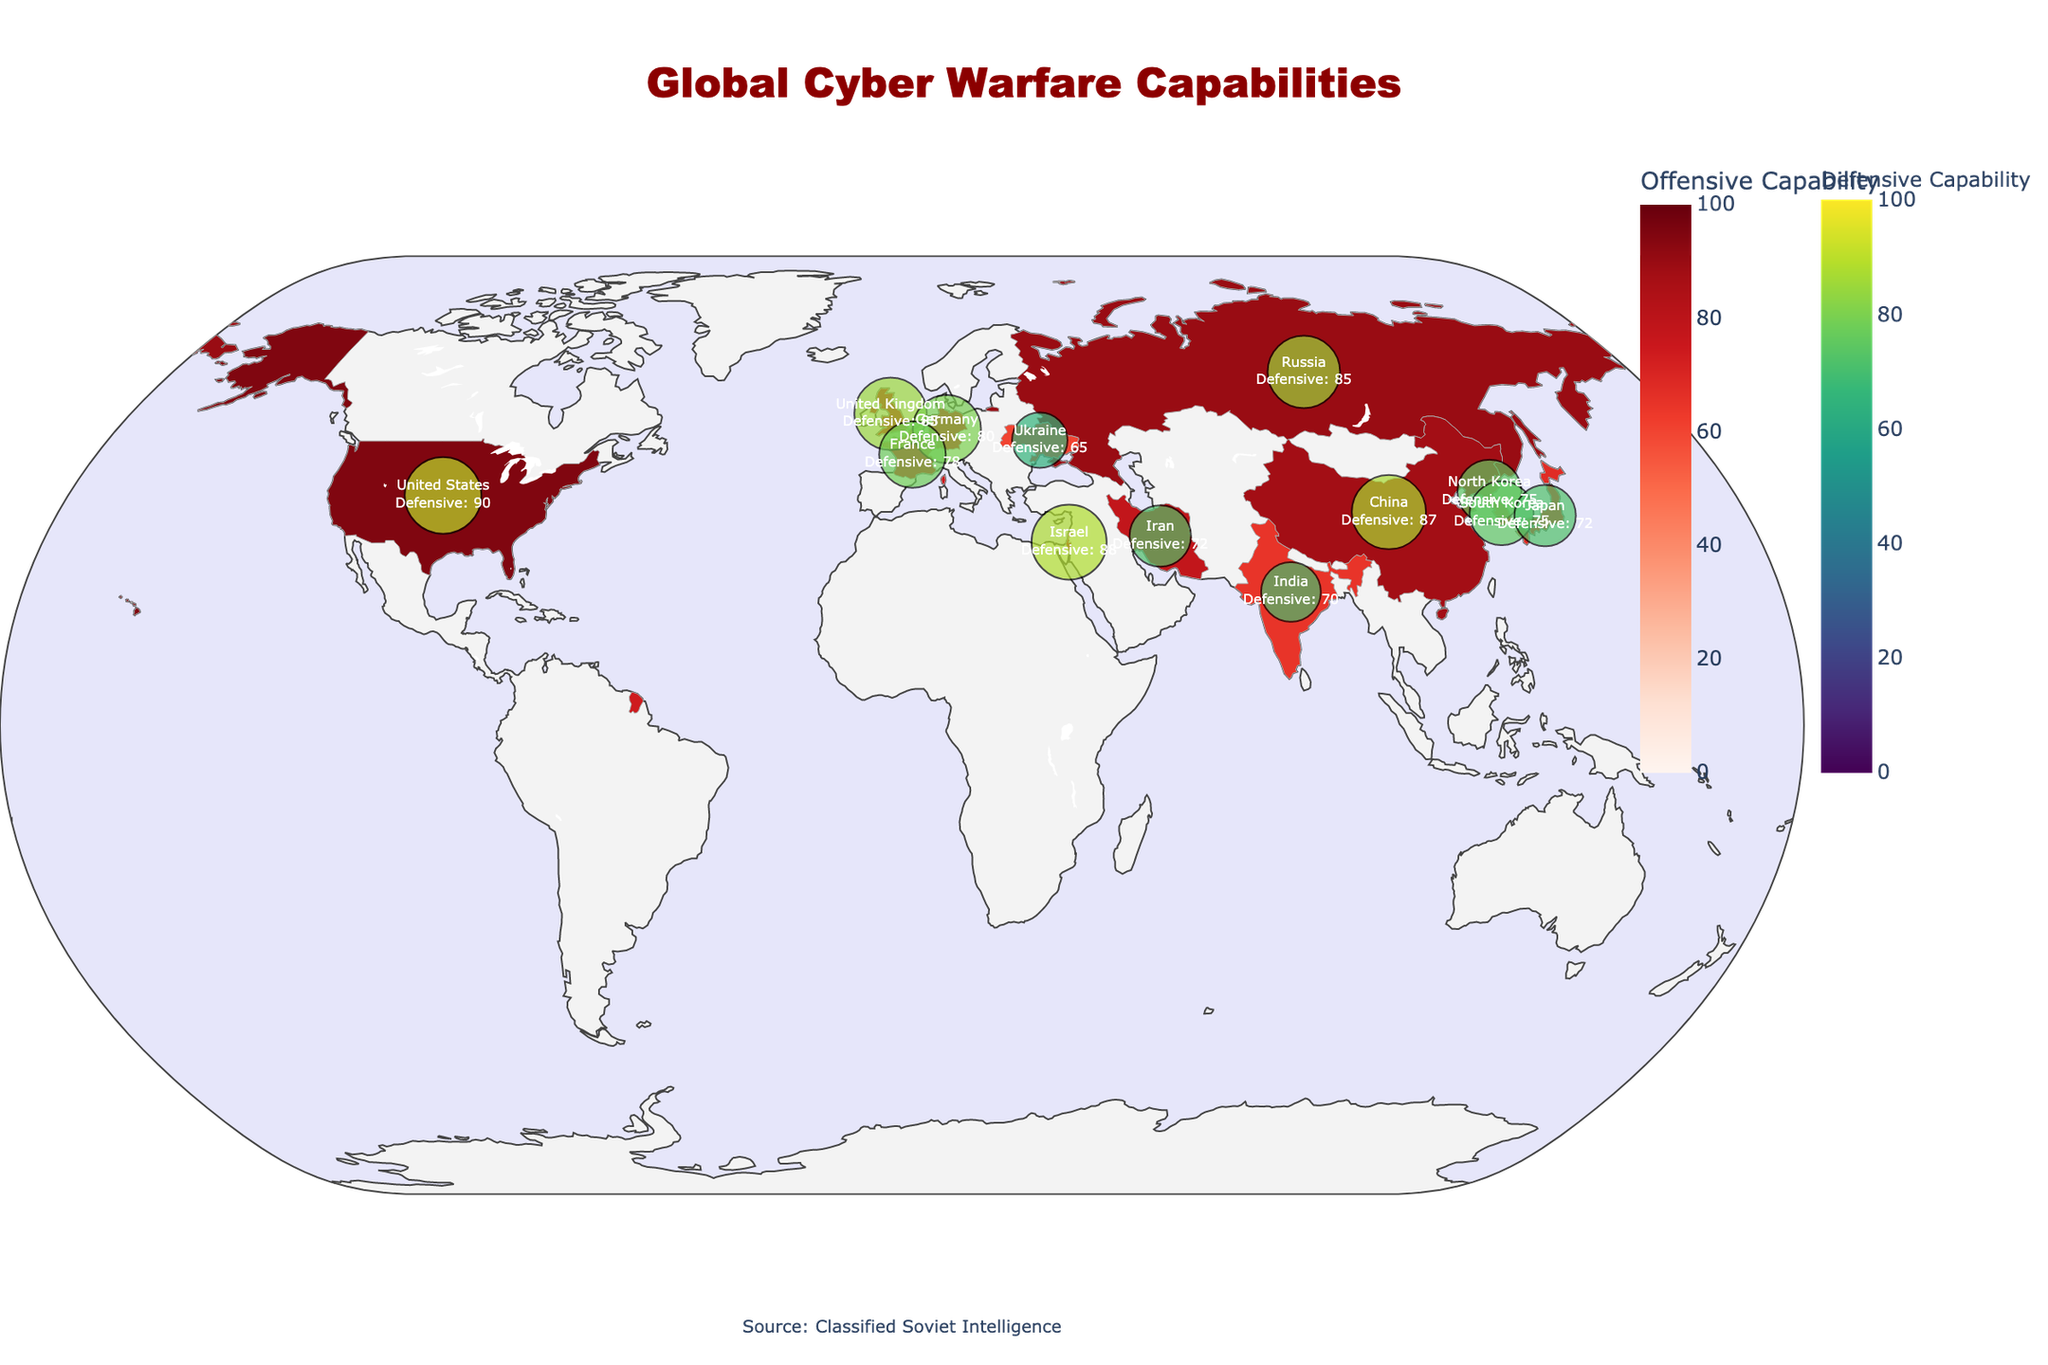How is a country's offensive cyber capability represented on the map? The offensive cyber capability of each country is represented by the color intensity on the choropleth map. Darker shades of red indicate higher capabilities.
Answer: By color intensity Which country has the highest offensive cyber capability and what is its value? Referring to the darkest shade of red on the map, the United States has the highest offensive cyber capability at a value of 95.
Answer: United States, 95 What is the relationship between a country's offensive and defensive cyber capabilities in the visualization? Countries are distinguished by their color shade for offensive capabilities and marked points for defensive capabilities. The scatter points show defensive scores, where bigger and darker points denote higher defensive capacities.
Answer: Represented by color and scatter points Between China and Israel, which country has a higher defensive capability and by how much? China has a defensive capability of 87, while Israel is marked with 88. Subtracting, Israel has 1 more point in defensive capability compared to China.
Answer: Israel, by 1 point How does North Korea's defensive capability compare to its offensive capability? North Korea's scatter point size and color indicate its defensive capability is 75, whereas the choropleth map shows an offensive capability of 80.
Answer: Lower; Defensive: 75, Offensive: 80 Identify a country with higher defensive than offensive cyber capabilities and state its values. Israel stands out with higher defensive capabilities (88) compared to its offensive capabilities (85).
Answer: Israel, Defense: 88, Offense: 85 Which countries have notable infrastructure related to their cyber capabilities mentioned in the visualization? The listed infrastructure appears next to the defensive scatter points. Countries include the United States (NSA), Russia (GRU), China (SSF), Israel (Unit 8200), the United Kingdom (GCHQ), North Korea (Bureau 121), Iran (Iranian Cyber Army), Germany (BSI), France (ANSSI), South Korea (NIS), Japan (NISC), India (DCA), and Ukraine (SSSCIP).
Answer: Thirteen countries What is the overall trend in offensive and defensive capabilities among the top five countries? The top five countries (United States, Russia, China, Israel, United Kingdom) exhibit both high offensive (range 82-95) and defensive capabilities (range 85-90), indicating a balanced cyber force.
Answer: High in both capabilities Compare the cyber capabilities of Iran and Germany. Which one has higher offensive and defensive strengths respectively? Iran's offensive capability is 78, with a defensive score of 72. Germany shows an offensive capability of 75 and a defensive strength of 80. So, Iran has a higher offensive score, while Germany has a higher defensive score.
Answer: Iran: Offensive; Germany: Defensive What does the size of the markers on the map indicate? The size of the markers on the scatter plot indicates the defensive capabilities of each country, with larger markers reflecting higher defensive scores.
Answer: Defensive Capability Size 